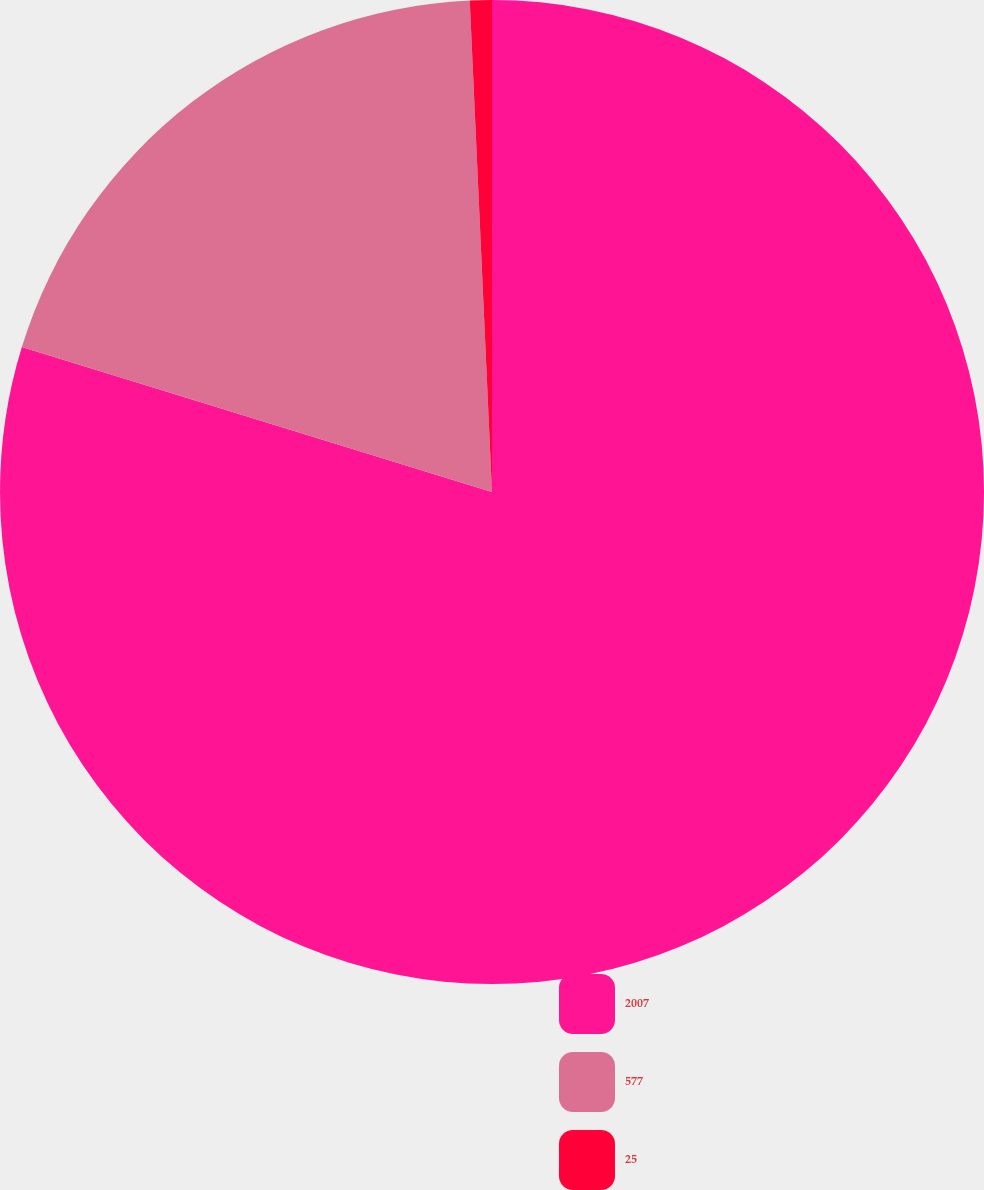<chart> <loc_0><loc_0><loc_500><loc_500><pie_chart><fcel>2007<fcel>577<fcel>25<nl><fcel>79.77%<fcel>19.52%<fcel>0.72%<nl></chart> 